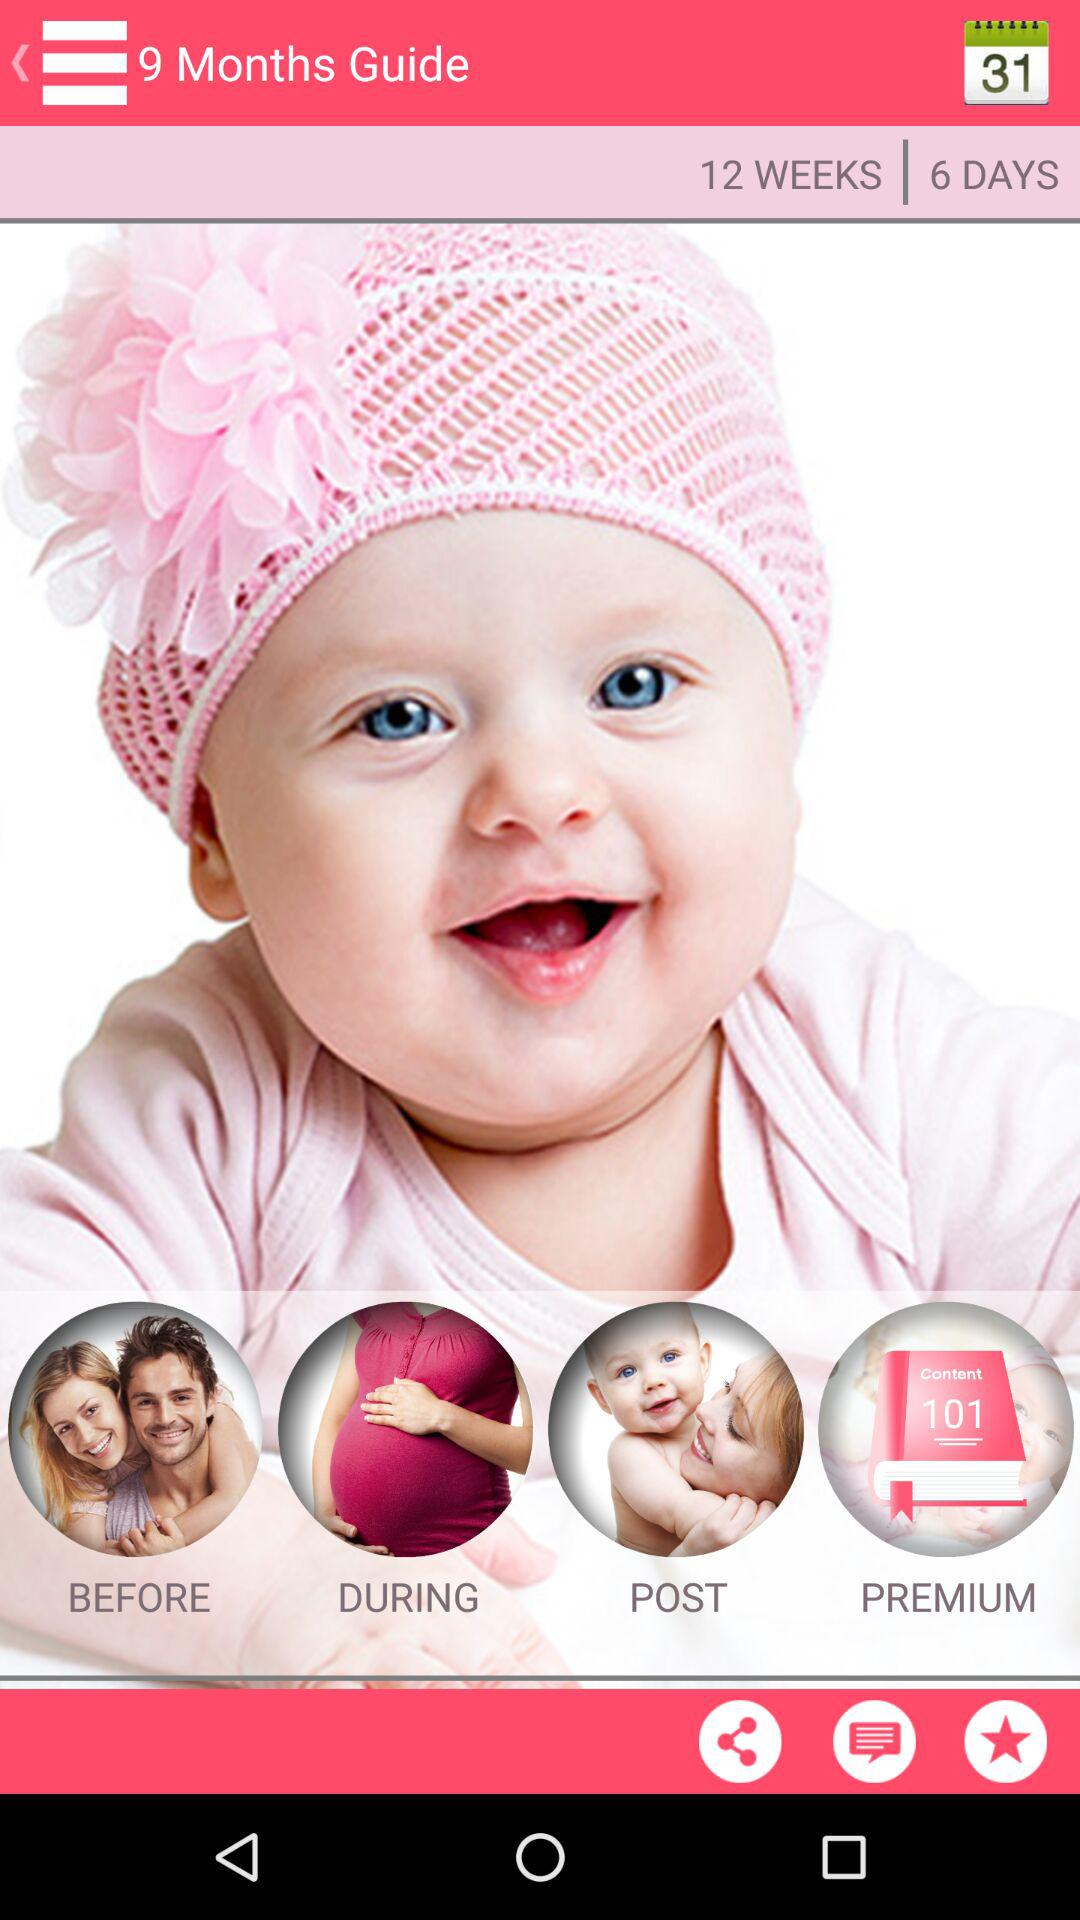How many days have been shown on the screen? The number of days shown on the screen is 6. 